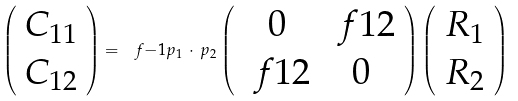<formula> <loc_0><loc_0><loc_500><loc_500>\left ( \begin{array} { c } C _ { 1 1 } \\ C _ { 1 2 } \end{array} \right ) = \ f { - 1 } { p _ { 1 } \, \cdot \, p _ { 2 } } \left ( \begin{array} { c c } 0 & \ f { 1 } { 2 } \\ \ f { 1 } { 2 } & 0 \end{array} \right ) \left ( \begin{array} { c } R _ { 1 } \\ R _ { 2 } \end{array} \right )</formula> 